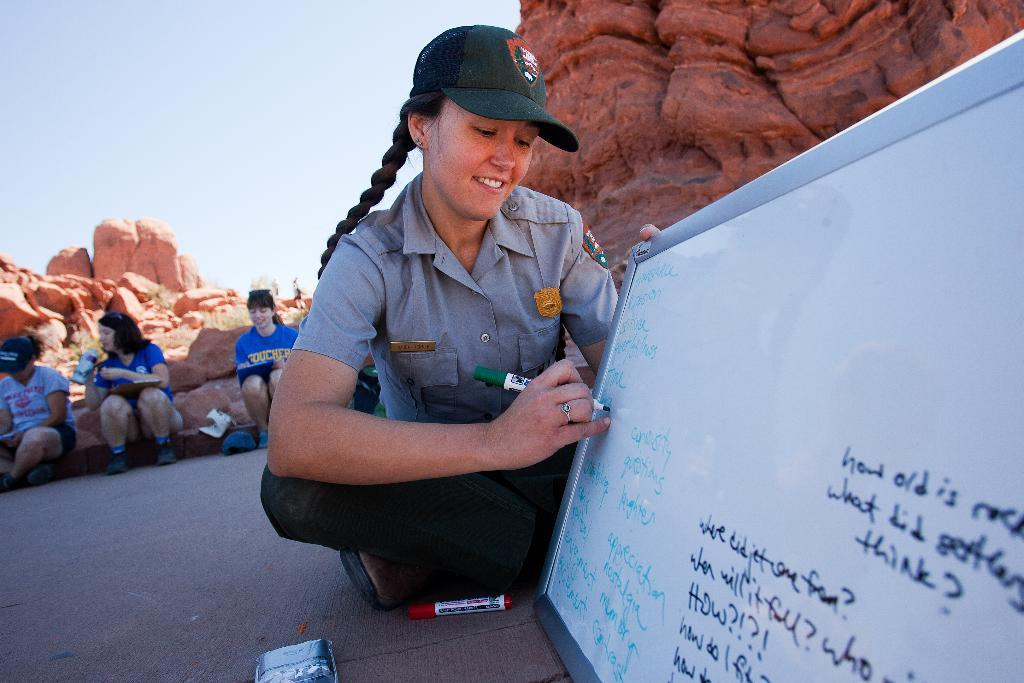What is the woman in the image doing? The woman is writing on a board. How many people are present in the image? There are three persons in the image. What can be seen in the background of the image? There are rocks and the sky visible in the background of the image. What type of art can be seen on the chairs in the image? There are no chairs present in the image, so it is not possible to determine if there is any art on them. 